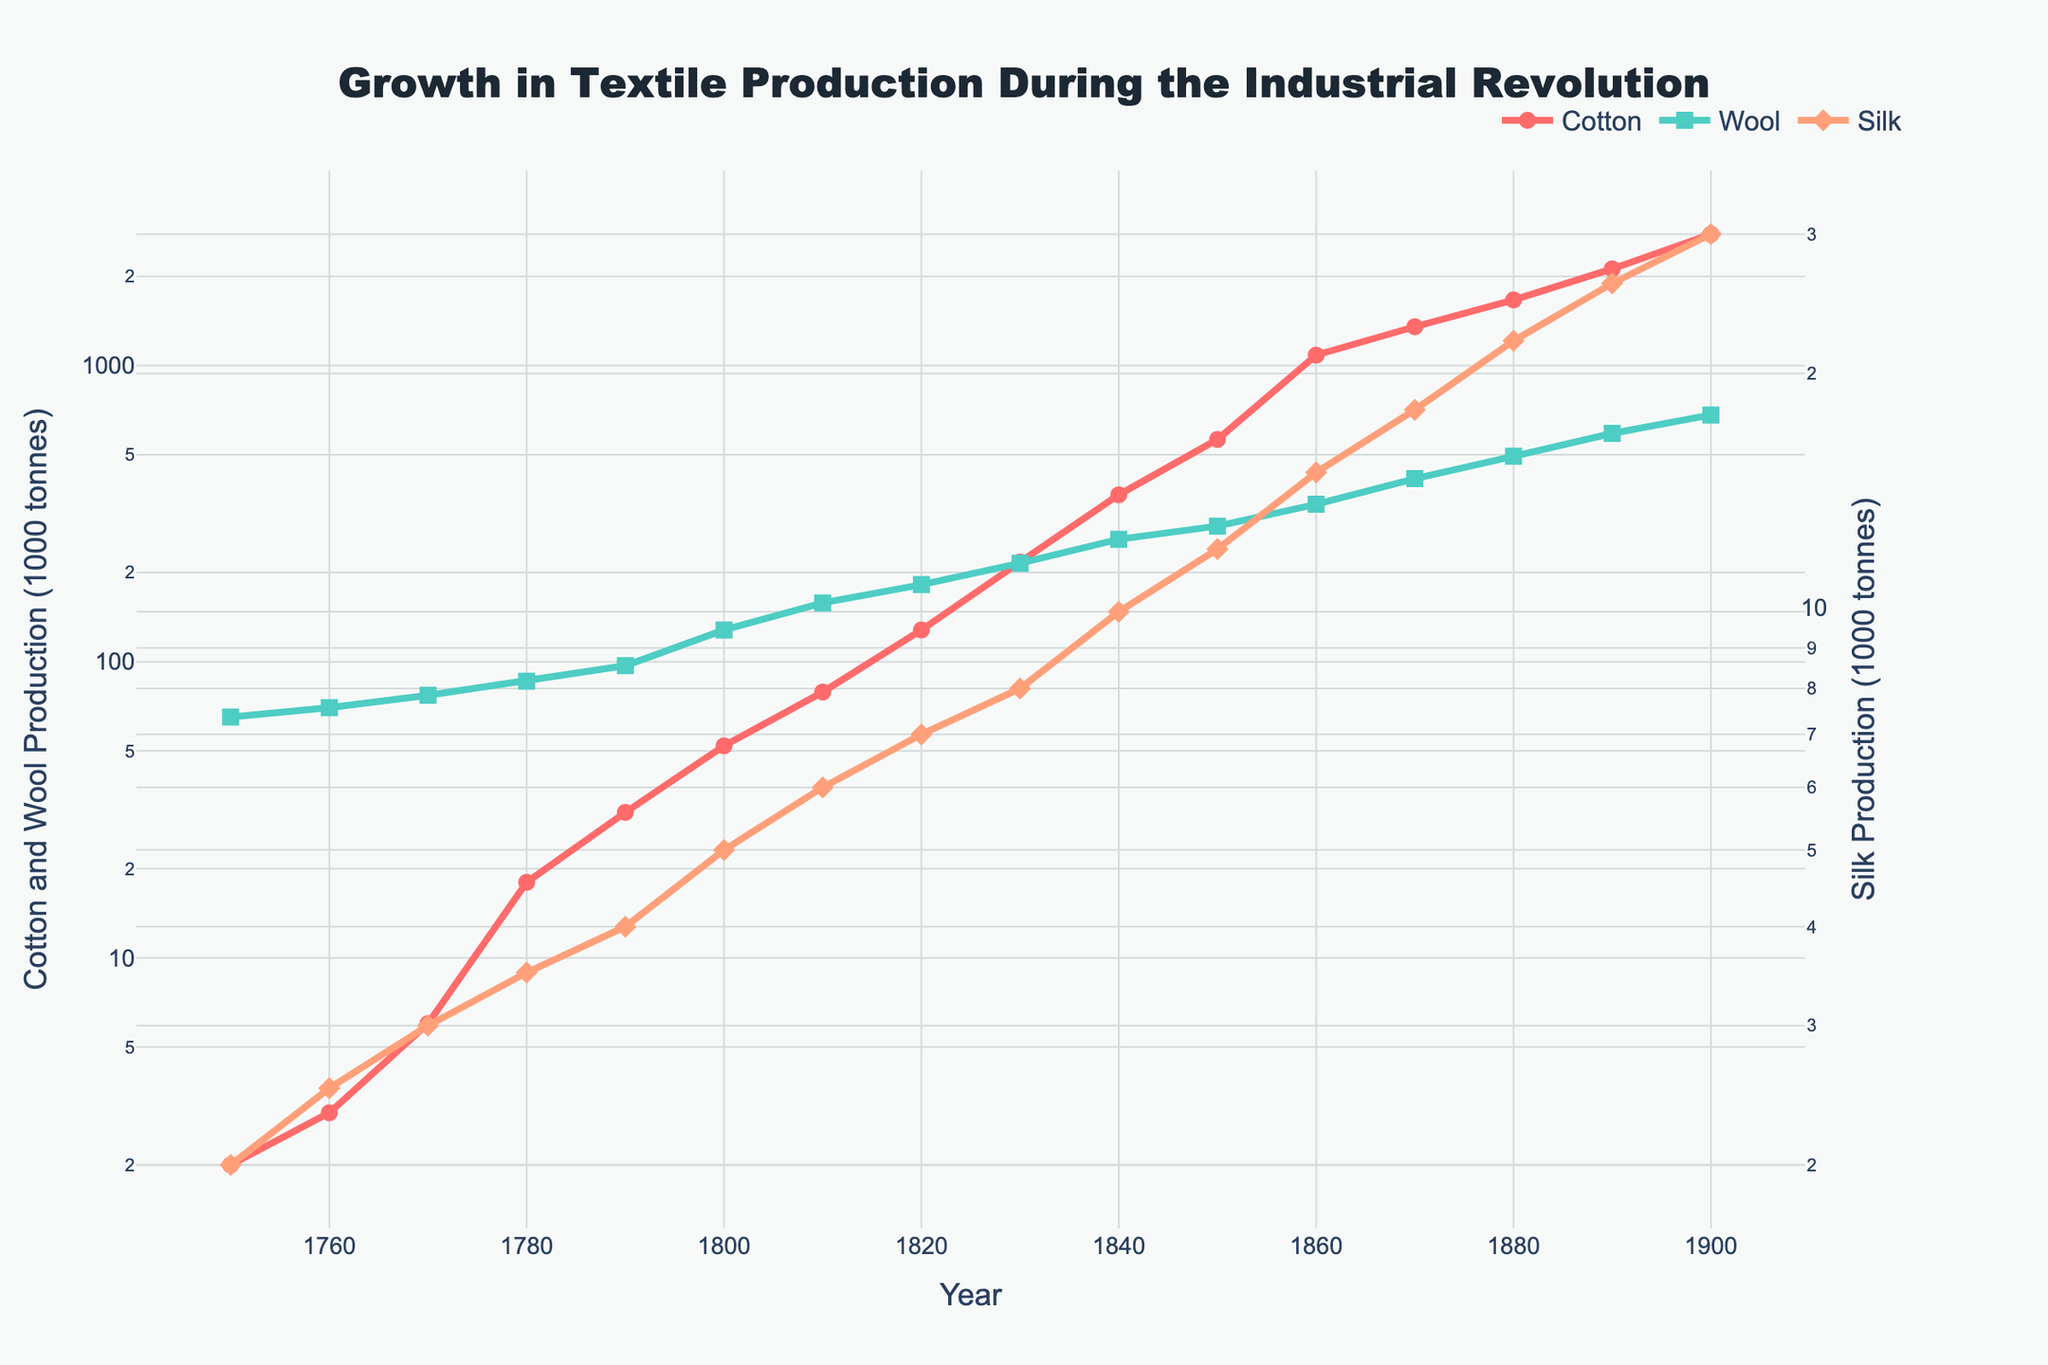What trends can be observed in the production of cotton, wool, and silk between 1750 and 1900? The cotton production shows a dramatic increase, especially after 1800, rising exponentially towards 1900. Wool production also increases steadily but not as steeply as cotton. Silk production shows a slow upward trend but remains much lower compared to cotton and wool.
Answer: Cotton: Dramatic increase, Wool: Steady increase, Silk: Slow upward trend What is the difference in cotton production between 1800 and 1900? In 1800, cotton production was 52,000 tonnes, and in 1900, it was 2,776,000 tonnes. Subtract the production in 1800 from the production in 1900: 2,776,000 - 52,000 = 2,724,000 tonnes.
Answer: 2,724,000 tonnes How does the wool production in 1800 compare to cotton production in 1800? In 1800, wool production was 128,000 tonnes, while cotton production was 52,000 tonnes. Wool production was higher than cotton production by: 128,000 - 52,000 = 76,000 tonnes.
Answer: 76,000 tonnes higher Which year marks the first instance where cotton production surpassed 1000,000 (1 million) tonnes? By examining the line chart for the cotton production, cotton production surpasses 1 million tonnes in 1860 where it reaches 1,084,000 tonnes.
Answer: 1860 By what factor did silk production increase from 1750 to 1900? In 1750, silk production was 2,000 tonnes, and in 1900, it was 30,000 tonnes. The factor of increase is determined by dividing the 1900 production by the 1750 production: 30,000 / 2,000 = 15.
Answer: 15 times Which textile had the highest production growth rate between 1770 and 1840? Calculate the growth rate for each textile over this period. Cotton grew from 6,000 to 366,000 tonnes, wool from 77,000 to 259,000 tonnes, and silk from 3,000 to 10,000 tonnes. Cotton shows the highest growth rate with an increase of: (366,000 - 6,000) / 6,000 = 60.
Answer: Cotton In what year does wool production first exceed 200,000 tonnes? Wool production exceeds 200,000 tonnes in 1830 where it is recorded at 215,000 tonnes.
Answer: 1830 Comparing the production of silk and wool in 1900, which one is produced more and by how much? In 1900, silk production was 30,000 tonnes, and wool production was 681,000 tonnes. Wool production exceeded silk production by: 681,000 - 30,000 = 651,000 tonnes.
Answer: 651,000 tonnes more How much did the production of wool change from 1800 to 1820? Wool production in 1800 was 128,000 tonnes, and in 1820 it was 182,000 tonnes. The change is: 182,000 - 128,000 = 54,000 tonnes.
Answer: 54,000 tonnes 